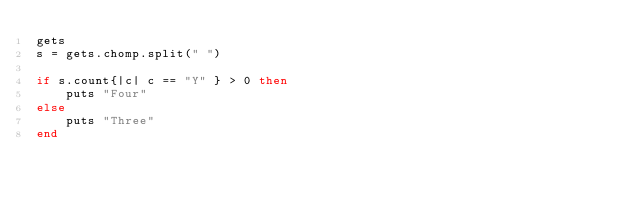<code> <loc_0><loc_0><loc_500><loc_500><_Ruby_>gets
s = gets.chomp.split(" ")

if s.count{|c| c == "Y" } > 0 then
    puts "Four"
else
    puts "Three"
end
</code> 